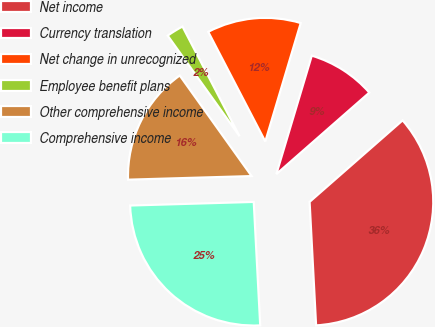<chart> <loc_0><loc_0><loc_500><loc_500><pie_chart><fcel>Net income<fcel>Currency translation<fcel>Net change in unrecognized<fcel>Employee benefit plans<fcel>Other comprehensive income<fcel>Comprehensive income<nl><fcel>35.62%<fcel>8.92%<fcel>12.26%<fcel>2.24%<fcel>15.59%<fcel>25.37%<nl></chart> 